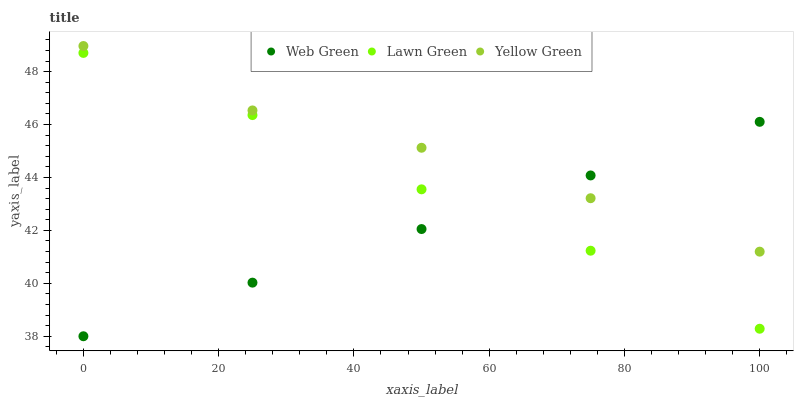Does Web Green have the minimum area under the curve?
Answer yes or no. Yes. Does Yellow Green have the maximum area under the curve?
Answer yes or no. Yes. Does Yellow Green have the minimum area under the curve?
Answer yes or no. No. Does Web Green have the maximum area under the curve?
Answer yes or no. No. Is Web Green the smoothest?
Answer yes or no. Yes. Is Yellow Green the roughest?
Answer yes or no. Yes. Is Yellow Green the smoothest?
Answer yes or no. No. Is Web Green the roughest?
Answer yes or no. No. Does Web Green have the lowest value?
Answer yes or no. Yes. Does Yellow Green have the lowest value?
Answer yes or no. No. Does Yellow Green have the highest value?
Answer yes or no. Yes. Does Web Green have the highest value?
Answer yes or no. No. Is Lawn Green less than Yellow Green?
Answer yes or no. Yes. Is Yellow Green greater than Lawn Green?
Answer yes or no. Yes. Does Web Green intersect Lawn Green?
Answer yes or no. Yes. Is Web Green less than Lawn Green?
Answer yes or no. No. Is Web Green greater than Lawn Green?
Answer yes or no. No. Does Lawn Green intersect Yellow Green?
Answer yes or no. No. 